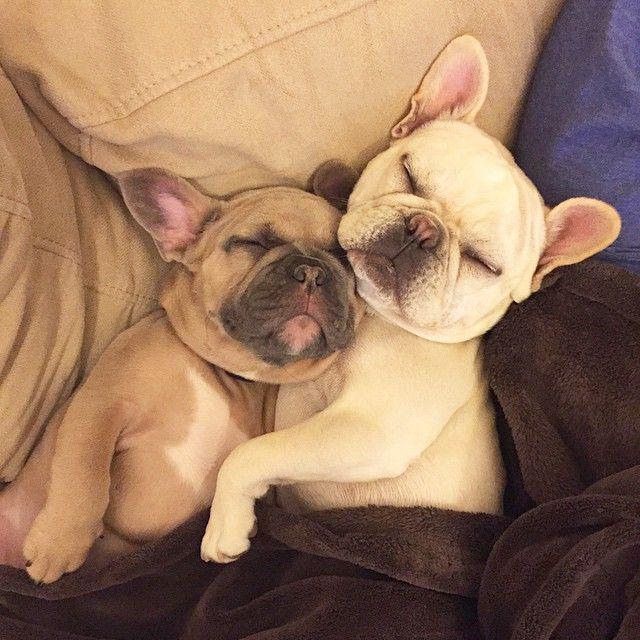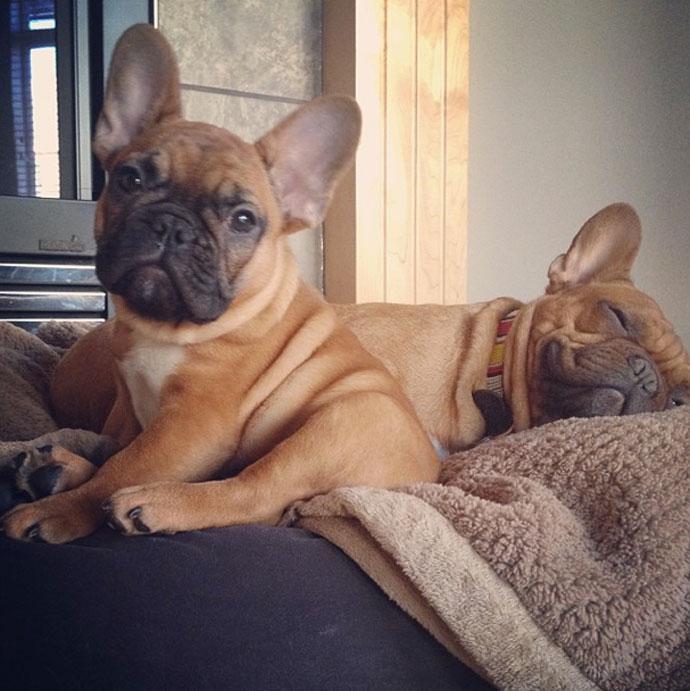The first image is the image on the left, the second image is the image on the right. Evaluate the accuracy of this statement regarding the images: "There is at least one black french bulldog that is hugging a white dog.". Is it true? Answer yes or no. No. The first image is the image on the left, the second image is the image on the right. For the images displayed, is the sentence "An image contains one black puppy with its front paws around one white puppy." factually correct? Answer yes or no. No. 